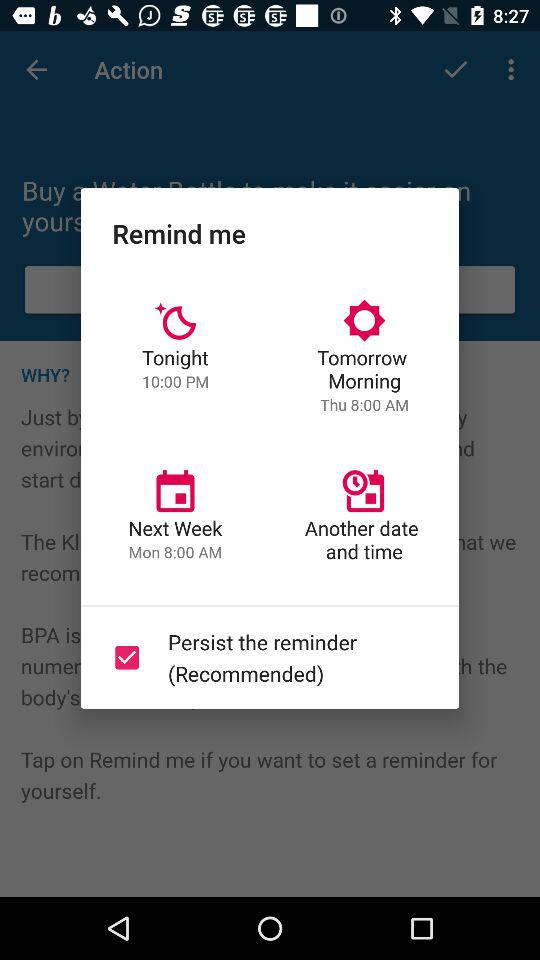How many reminder options are available?
Answer the question using a single word or phrase. 4 